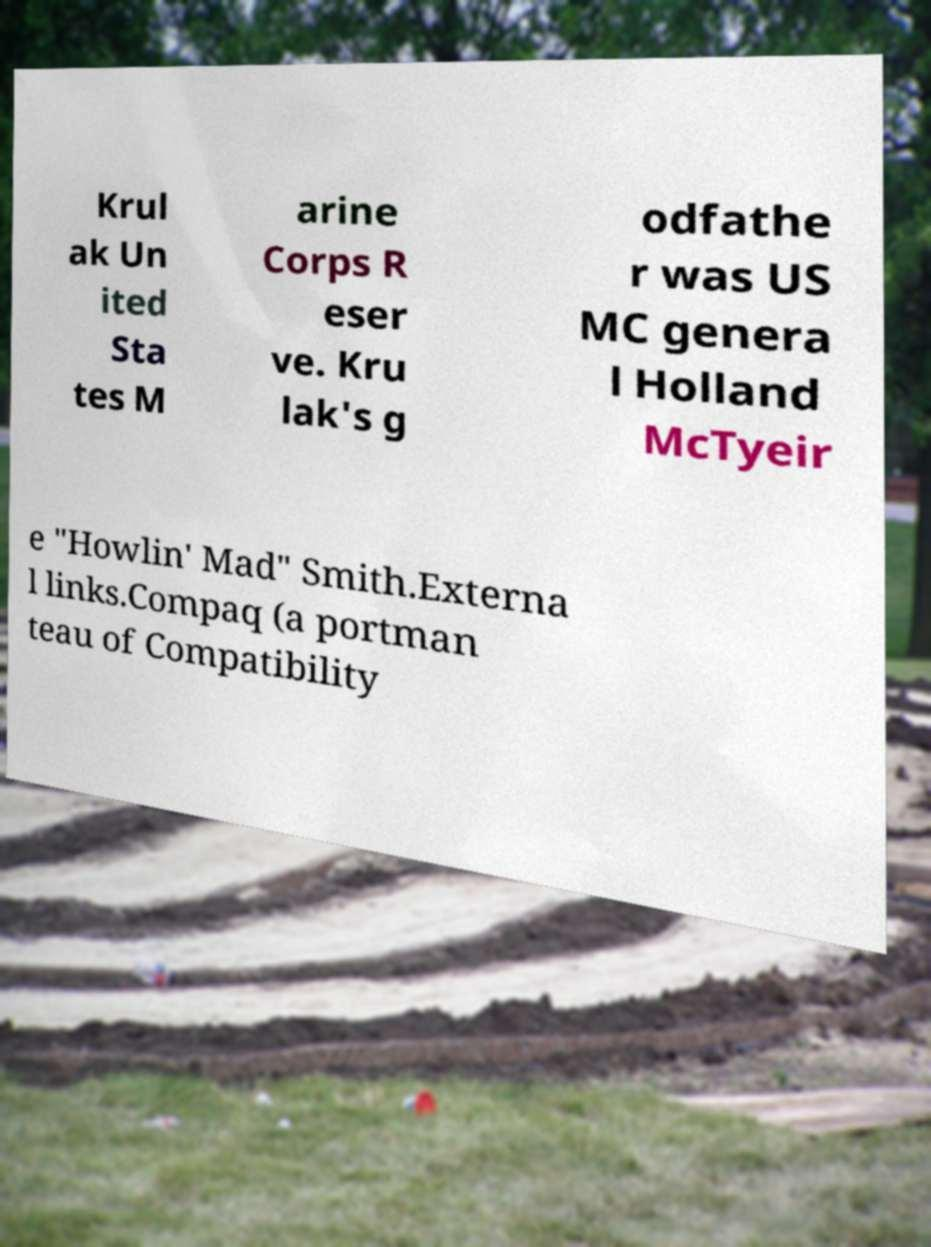Could you extract and type out the text from this image? Krul ak Un ited Sta tes M arine Corps R eser ve. Kru lak's g odfathe r was US MC genera l Holland McTyeir e "Howlin' Mad" Smith.Externa l links.Compaq (a portman teau of Compatibility 